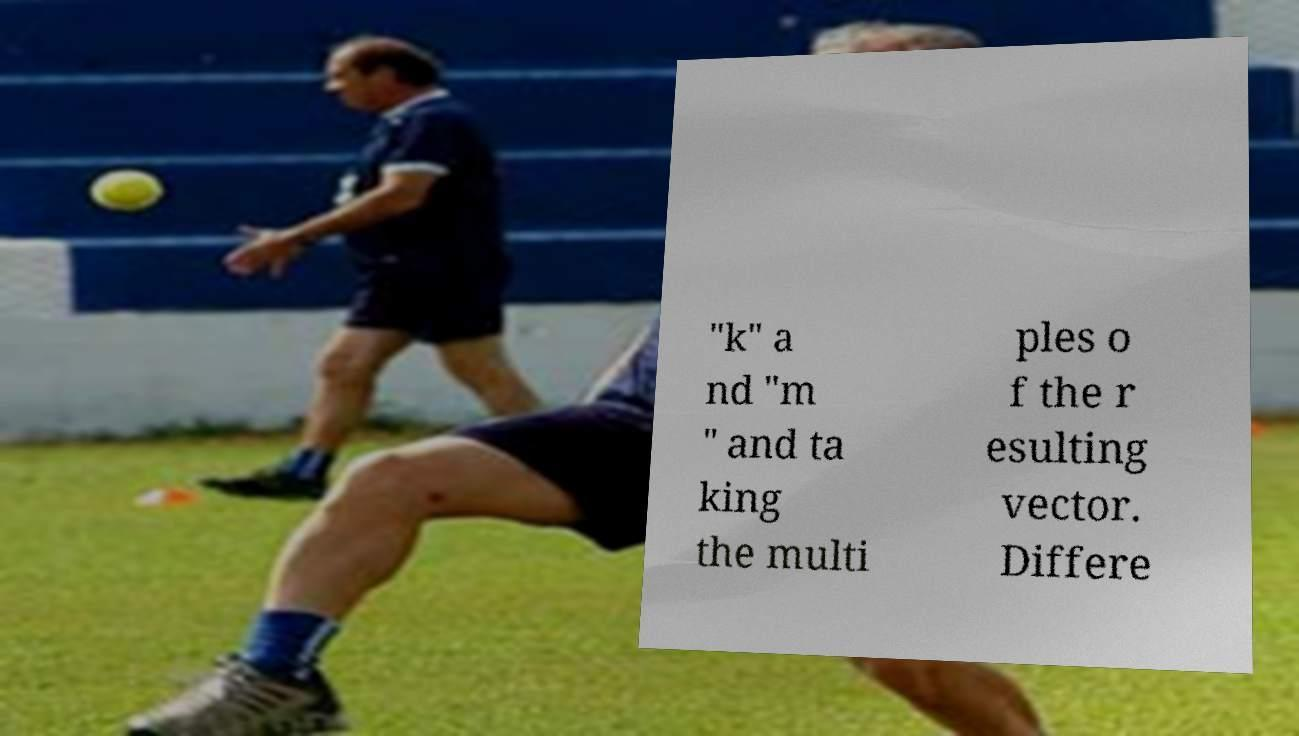There's text embedded in this image that I need extracted. Can you transcribe it verbatim? "k" a nd "m " and ta king the multi ples o f the r esulting vector. Differe 